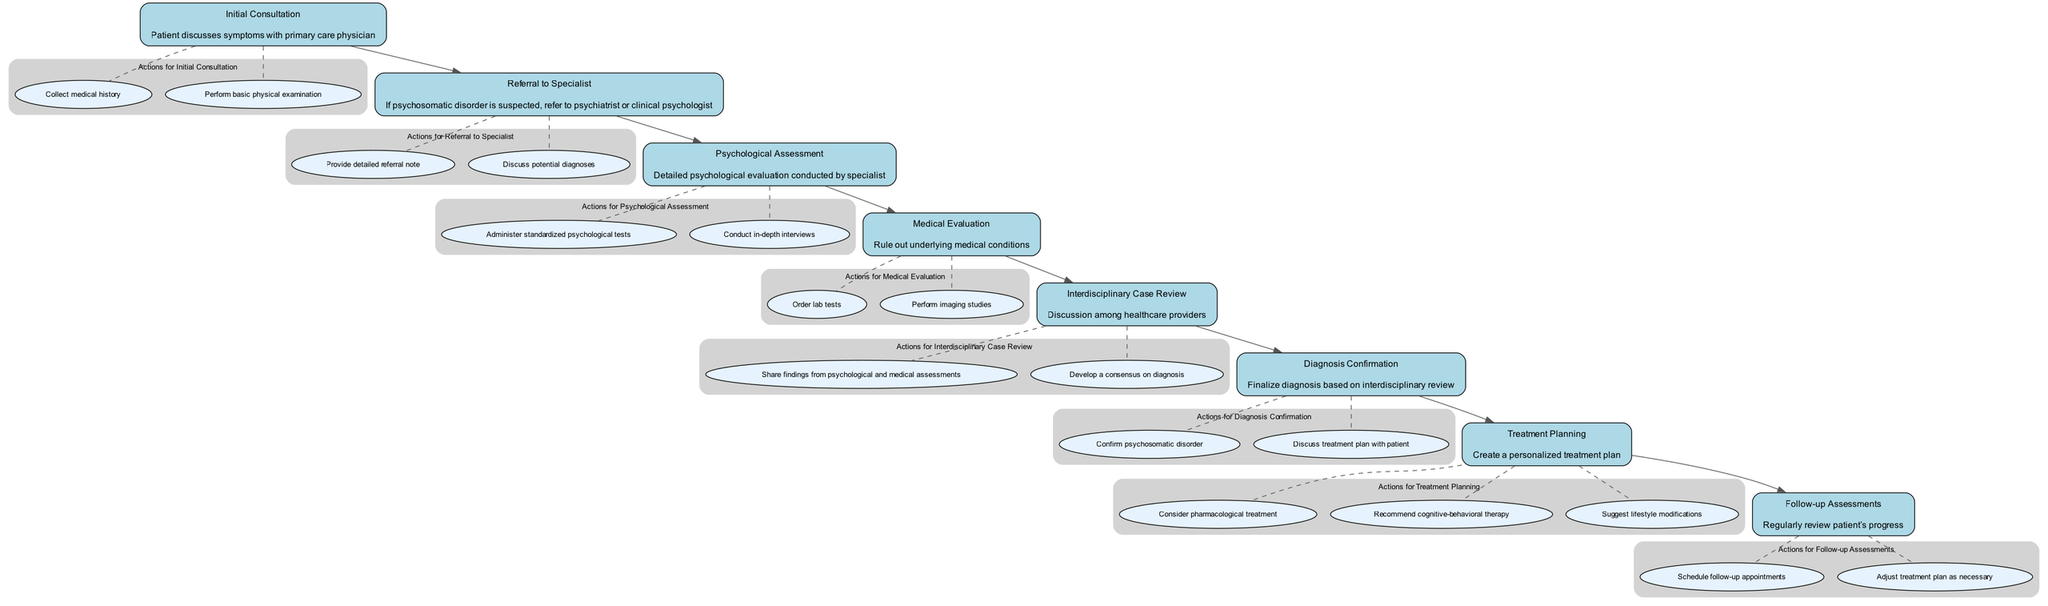What is the first step in the clinical pathway? The clinical pathway starts with the "Initial Consultation" where the patient discusses symptoms with the primary care physician.
Answer: Initial Consultation How many actions are listed under "Diagnosis Confirmation"? "Diagnosis Confirmation" has two actions listed: confirming the psychosomatic disorder and discussing the treatment plan with the patient.
Answer: 2 What follows the "Psychological Assessment"? After the "Psychological Assessment", the next step in the pathway is "Medical Evaluation", which is aimed at ruling out underlying medical conditions.
Answer: Medical Evaluation What types of specialists are involved in the referral process? The referral process involves either a psychiatrist or a clinical psychologist, depending on the suspicion of a psychosomatic disorder.
Answer: Psychiatrist or clinical psychologist In which step are standardized psychological tests administered? Standardized psychological tests are administered during the "Psychological Assessment" step that follows the referral to the specialist.
Answer: Psychological Assessment What is the primary goal of the "Interdisciplinary Case Review"? The main goal of the "Interdisciplinary Case Review" is to share findings from psychological and medical assessments and reach a consensus on the diagnosis from various healthcare providers.
Answer: Consensus on diagnosis How many nodes are there in total in the clinical pathway? The diagram consists of eight nodes, representing each distinct step in the clinical pathway from consultation to follow-up assessments.
Answer: 8 What is the final step in the clinical pathway? The final step in the clinical pathway is "Follow-up Assessments," which focuses on regularly reviewing the patient's progress.
Answer: Follow-up Assessments 